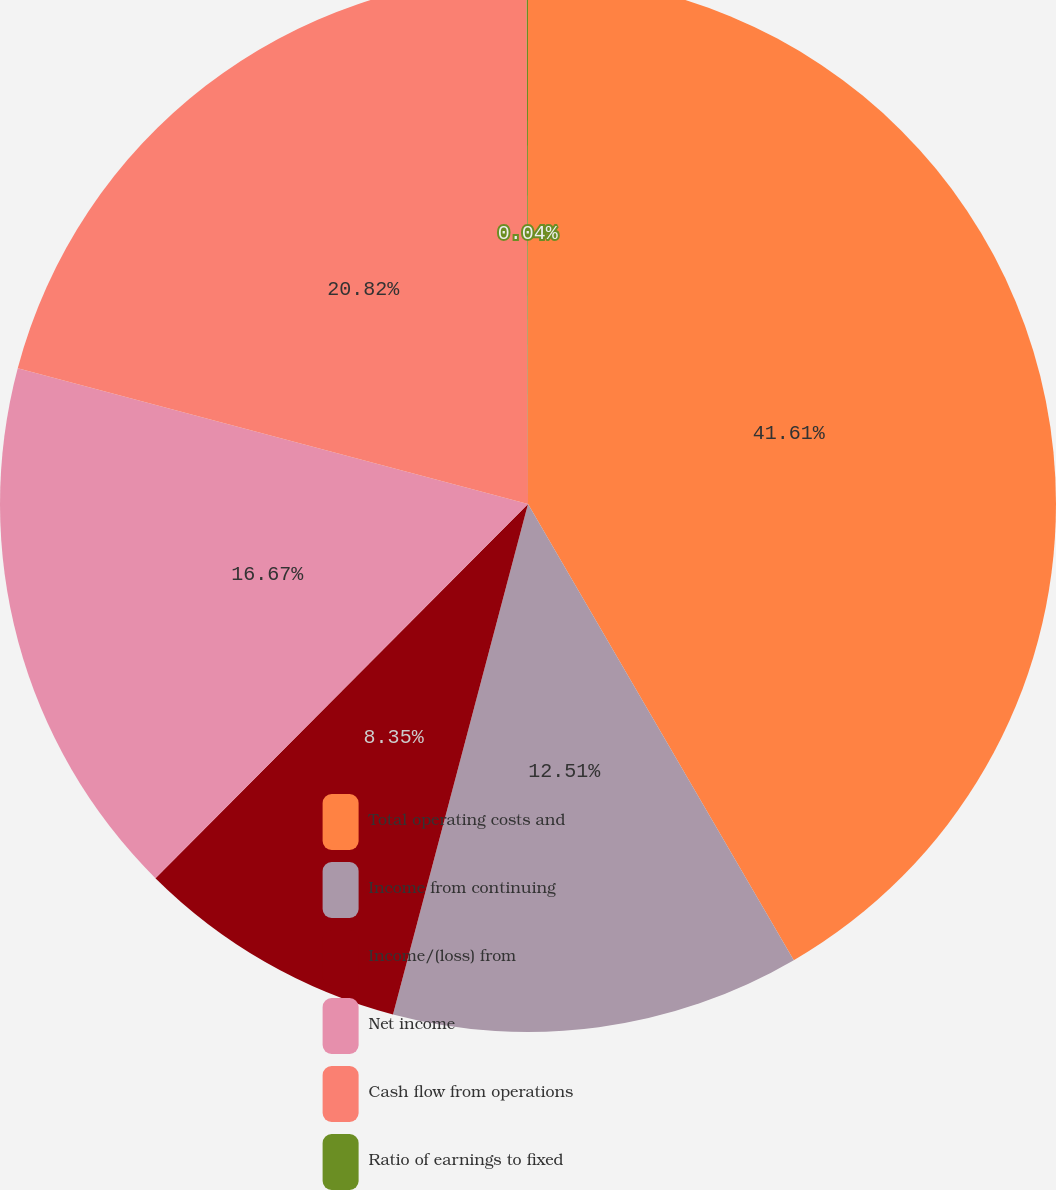<chart> <loc_0><loc_0><loc_500><loc_500><pie_chart><fcel>Total operating costs and<fcel>Income from continuing<fcel>Income/(loss) from<fcel>Net income<fcel>Cash flow from operations<fcel>Ratio of earnings to fixed<nl><fcel>41.6%<fcel>12.51%<fcel>8.35%<fcel>16.67%<fcel>20.82%<fcel>0.04%<nl></chart> 